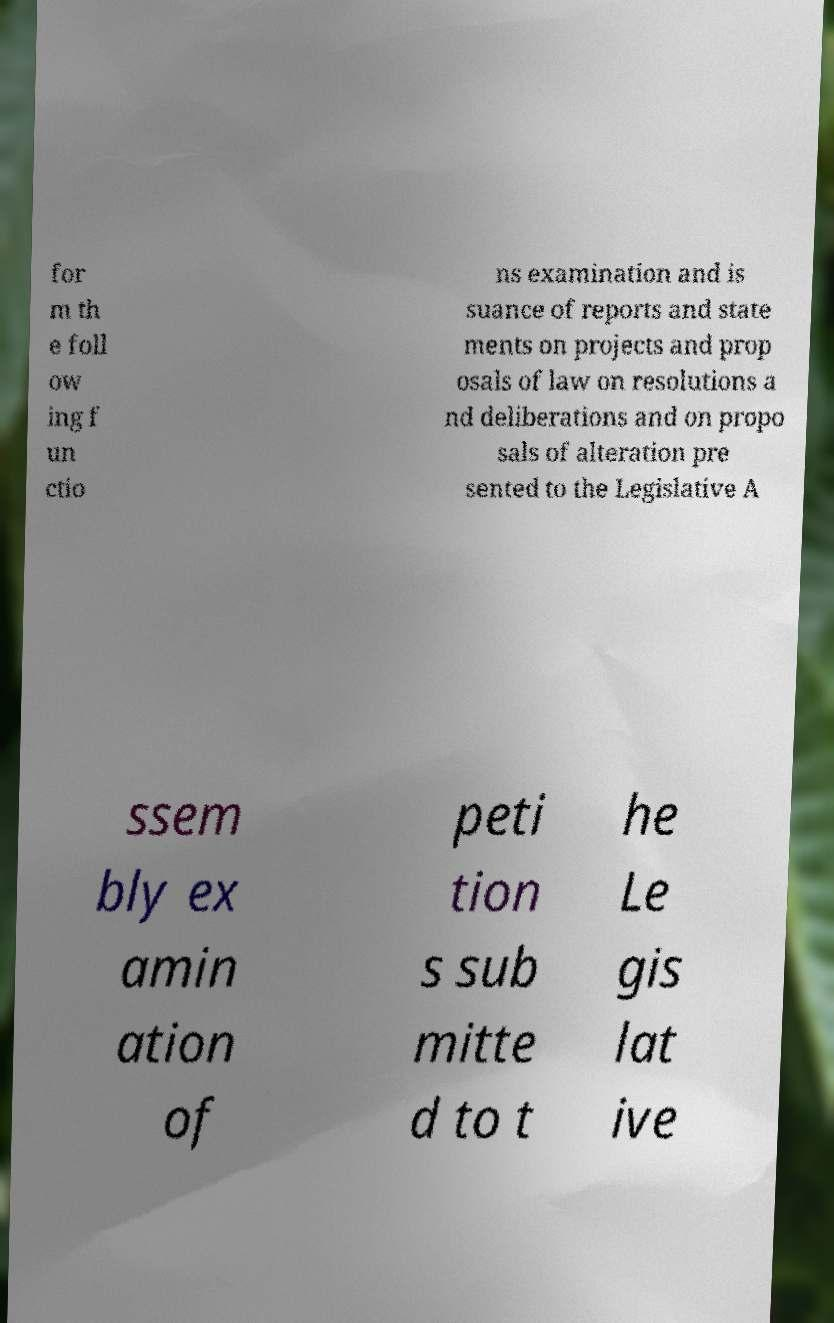Could you assist in decoding the text presented in this image and type it out clearly? for m th e foll ow ing f un ctio ns examination and is suance of reports and state ments on projects and prop osals of law on resolutions a nd deliberations and on propo sals of alteration pre sented to the Legislative A ssem bly ex amin ation of peti tion s sub mitte d to t he Le gis lat ive 